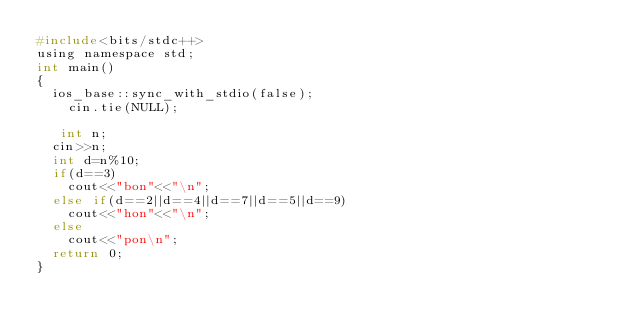<code> <loc_0><loc_0><loc_500><loc_500><_C_>#include<bits/stdc++>
using namespace std;
int main()
{
  ios_base::sync_with_stdio(false);
    cin.tie(NULL);
    
   int n;
  cin>>n;
  int d=n%10;
  if(d==3)
    cout<<"bon"<<"\n";
  else if(d==2||d==4||d==7||d==5||d==9)
    cout<<"hon"<<"\n";
  else
    cout<<"pon\n";
  return 0;
}</code> 